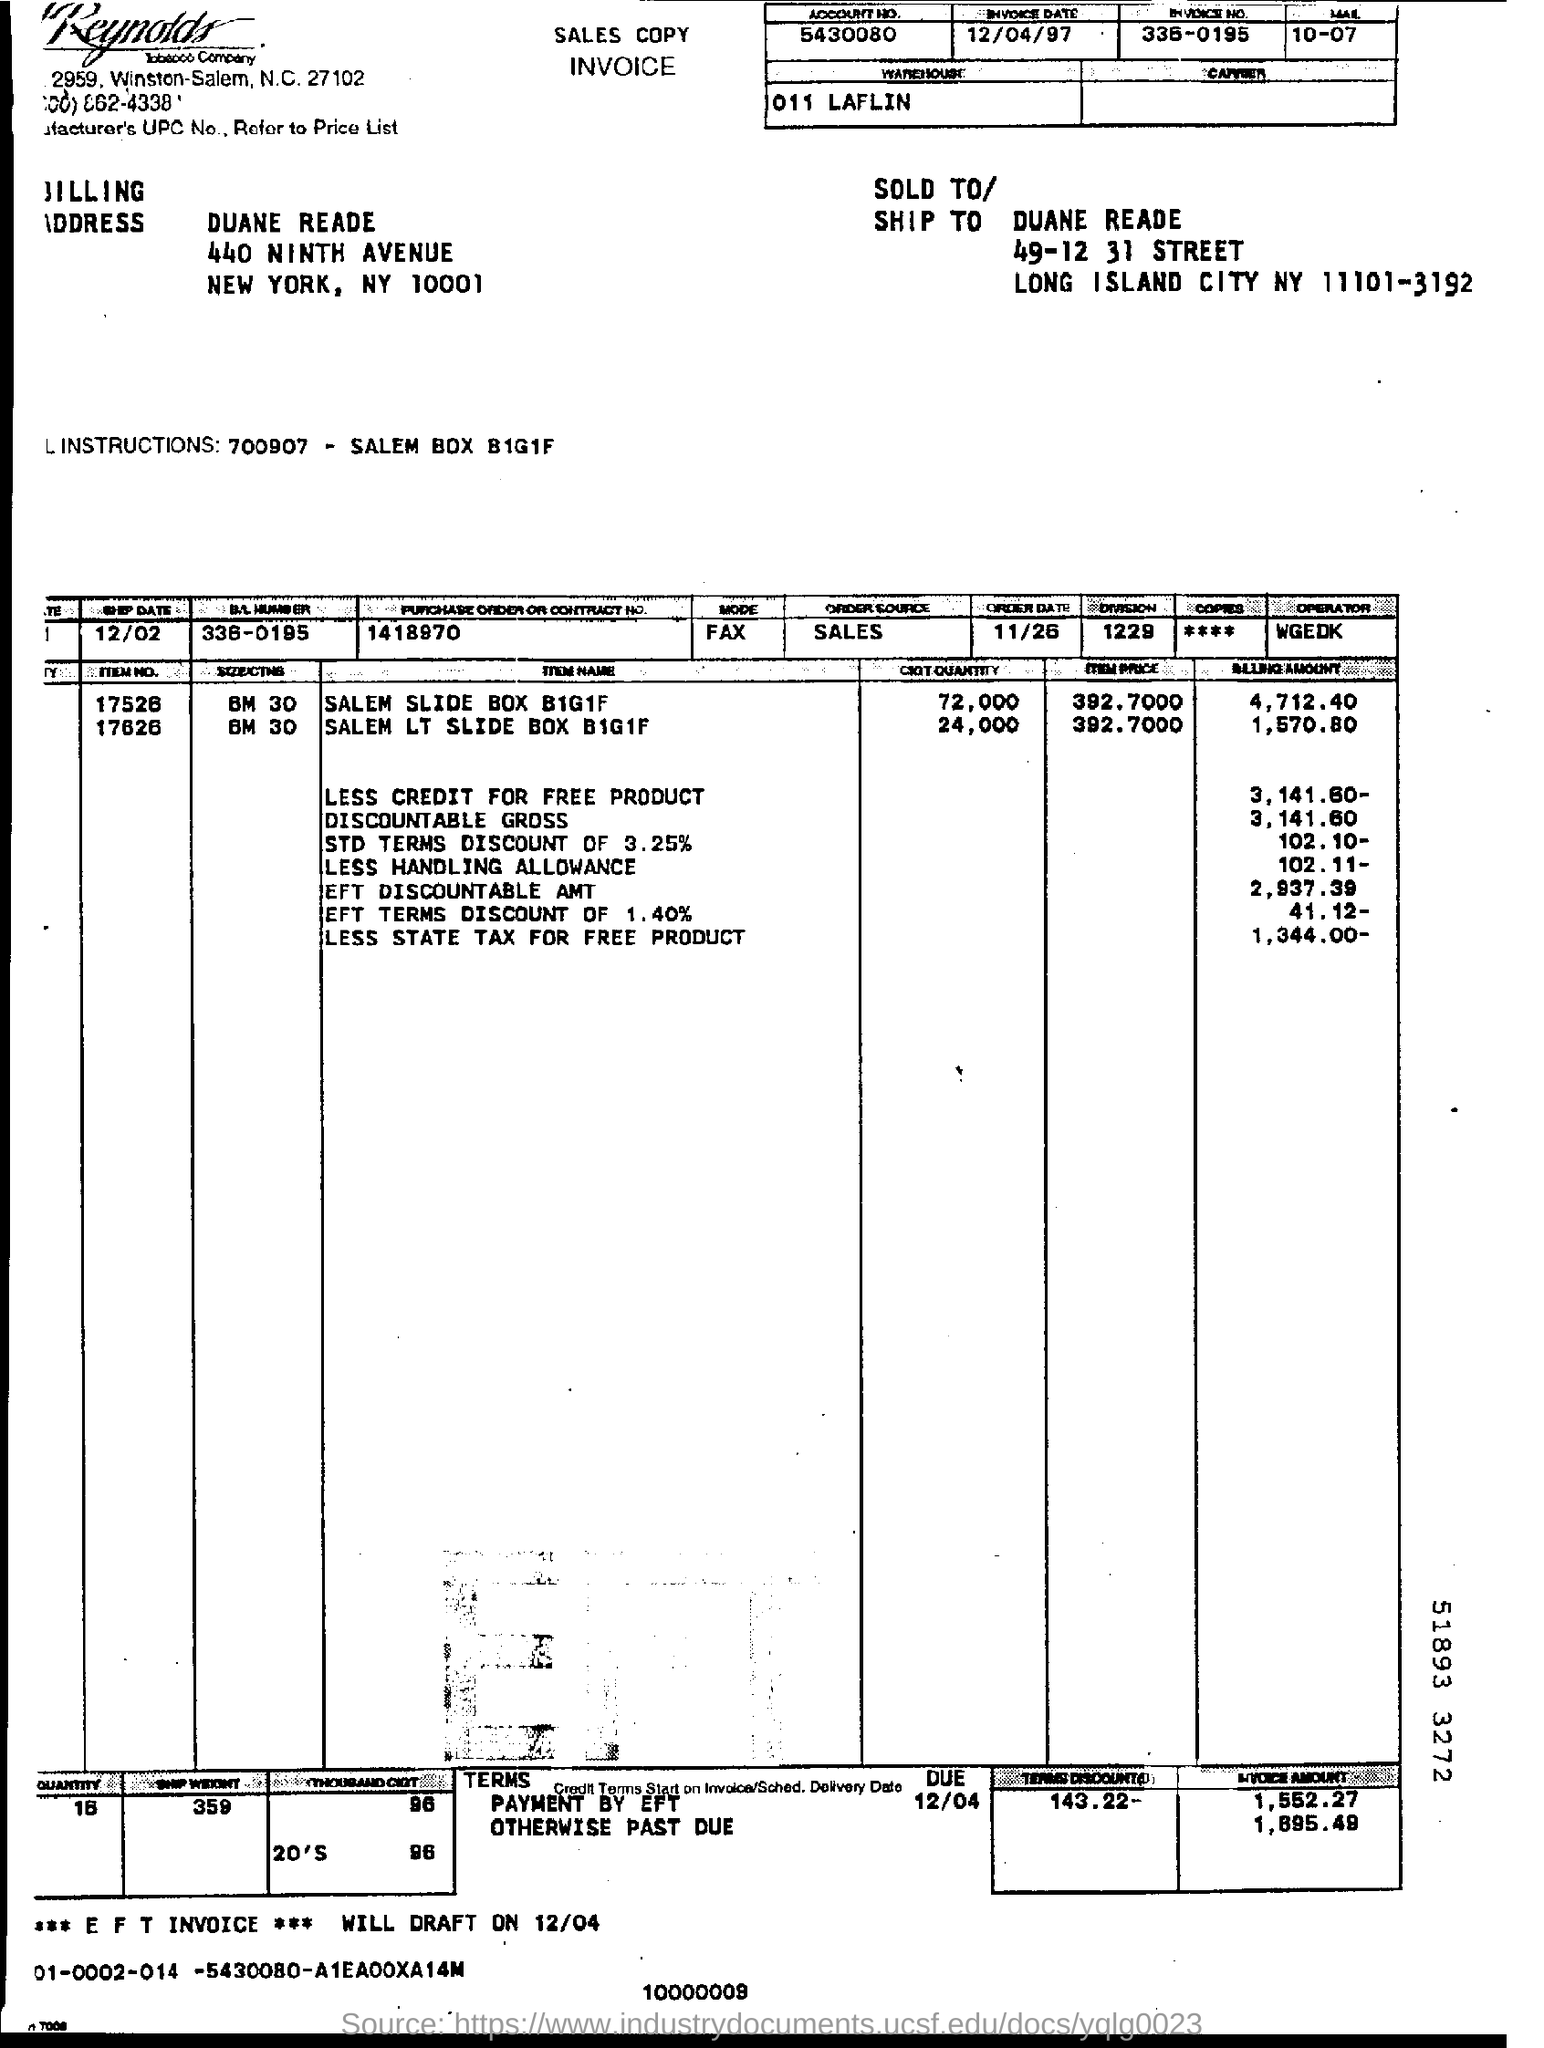Indicate a few pertinent items in this graphic. The billing amount for SALEM SLIDE BOX B1G1F is 4,712.40. 